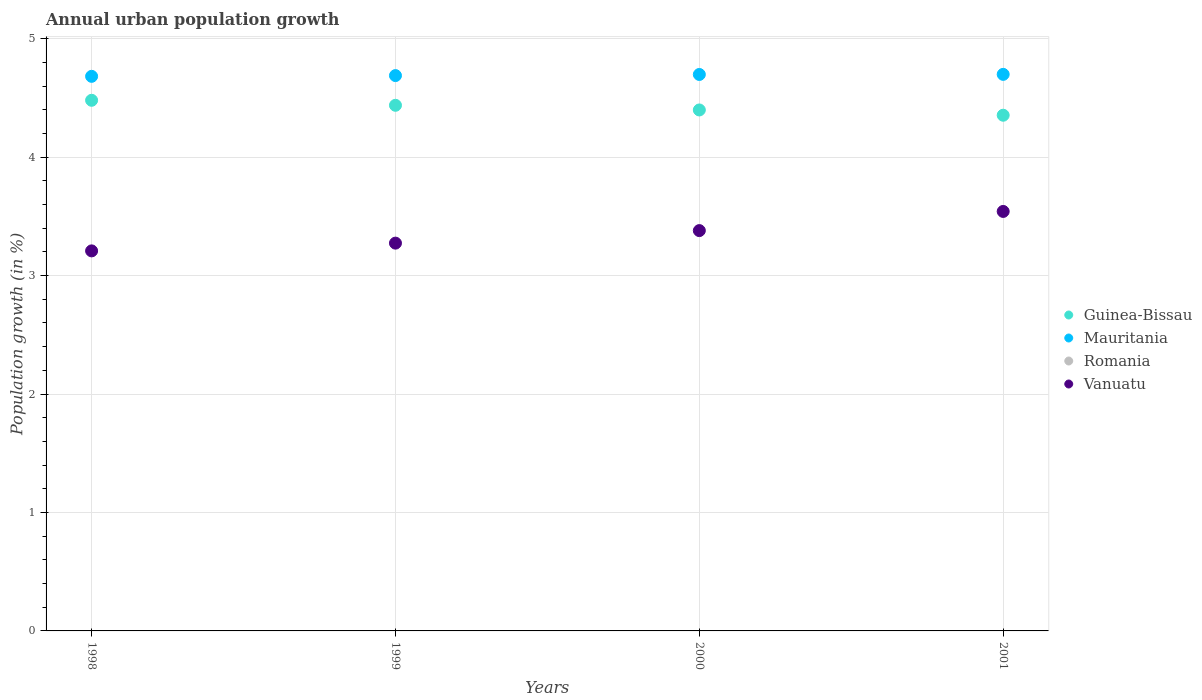Is the number of dotlines equal to the number of legend labels?
Provide a short and direct response. No. What is the percentage of urban population growth in Mauritania in 1999?
Give a very brief answer. 4.69. Across all years, what is the maximum percentage of urban population growth in Guinea-Bissau?
Keep it short and to the point. 4.48. Across all years, what is the minimum percentage of urban population growth in Mauritania?
Provide a succinct answer. 4.68. In which year was the percentage of urban population growth in Guinea-Bissau maximum?
Ensure brevity in your answer.  1998. What is the total percentage of urban population growth in Mauritania in the graph?
Provide a succinct answer. 18.77. What is the difference between the percentage of urban population growth in Guinea-Bissau in 1998 and that in 2001?
Keep it short and to the point. 0.13. What is the difference between the percentage of urban population growth in Guinea-Bissau in 1998 and the percentage of urban population growth in Mauritania in 2000?
Keep it short and to the point. -0.22. What is the average percentage of urban population growth in Romania per year?
Your answer should be compact. 0. In the year 1998, what is the difference between the percentage of urban population growth in Mauritania and percentage of urban population growth in Vanuatu?
Your answer should be compact. 1.47. In how many years, is the percentage of urban population growth in Romania greater than 0.8 %?
Offer a terse response. 0. What is the ratio of the percentage of urban population growth in Guinea-Bissau in 1998 to that in 1999?
Offer a terse response. 1.01. What is the difference between the highest and the second highest percentage of urban population growth in Vanuatu?
Your answer should be compact. 0.16. What is the difference between the highest and the lowest percentage of urban population growth in Mauritania?
Offer a very short reply. 0.02. Does the percentage of urban population growth in Vanuatu monotonically increase over the years?
Your answer should be very brief. Yes. Is the percentage of urban population growth in Mauritania strictly less than the percentage of urban population growth in Guinea-Bissau over the years?
Your answer should be compact. No. Are the values on the major ticks of Y-axis written in scientific E-notation?
Offer a terse response. No. How are the legend labels stacked?
Provide a succinct answer. Vertical. What is the title of the graph?
Offer a terse response. Annual urban population growth. What is the label or title of the Y-axis?
Keep it short and to the point. Population growth (in %). What is the Population growth (in %) of Guinea-Bissau in 1998?
Offer a very short reply. 4.48. What is the Population growth (in %) in Mauritania in 1998?
Keep it short and to the point. 4.68. What is the Population growth (in %) in Romania in 1998?
Offer a very short reply. 0. What is the Population growth (in %) of Vanuatu in 1998?
Provide a succinct answer. 3.21. What is the Population growth (in %) in Guinea-Bissau in 1999?
Your answer should be compact. 4.44. What is the Population growth (in %) of Mauritania in 1999?
Provide a short and direct response. 4.69. What is the Population growth (in %) of Vanuatu in 1999?
Give a very brief answer. 3.27. What is the Population growth (in %) of Guinea-Bissau in 2000?
Your answer should be very brief. 4.4. What is the Population growth (in %) in Mauritania in 2000?
Your answer should be very brief. 4.7. What is the Population growth (in %) in Vanuatu in 2000?
Your response must be concise. 3.38. What is the Population growth (in %) in Guinea-Bissau in 2001?
Provide a succinct answer. 4.35. What is the Population growth (in %) of Mauritania in 2001?
Ensure brevity in your answer.  4.7. What is the Population growth (in %) of Vanuatu in 2001?
Ensure brevity in your answer.  3.54. Across all years, what is the maximum Population growth (in %) of Guinea-Bissau?
Provide a short and direct response. 4.48. Across all years, what is the maximum Population growth (in %) in Mauritania?
Give a very brief answer. 4.7. Across all years, what is the maximum Population growth (in %) of Vanuatu?
Your response must be concise. 3.54. Across all years, what is the minimum Population growth (in %) of Guinea-Bissau?
Make the answer very short. 4.35. Across all years, what is the minimum Population growth (in %) in Mauritania?
Offer a terse response. 4.68. Across all years, what is the minimum Population growth (in %) in Vanuatu?
Your answer should be very brief. 3.21. What is the total Population growth (in %) of Guinea-Bissau in the graph?
Your response must be concise. 17.67. What is the total Population growth (in %) of Mauritania in the graph?
Make the answer very short. 18.77. What is the total Population growth (in %) in Romania in the graph?
Ensure brevity in your answer.  0. What is the total Population growth (in %) of Vanuatu in the graph?
Ensure brevity in your answer.  13.4. What is the difference between the Population growth (in %) in Guinea-Bissau in 1998 and that in 1999?
Offer a very short reply. 0.04. What is the difference between the Population growth (in %) in Mauritania in 1998 and that in 1999?
Provide a succinct answer. -0.01. What is the difference between the Population growth (in %) of Vanuatu in 1998 and that in 1999?
Offer a very short reply. -0.07. What is the difference between the Population growth (in %) of Guinea-Bissau in 1998 and that in 2000?
Ensure brevity in your answer.  0.08. What is the difference between the Population growth (in %) in Mauritania in 1998 and that in 2000?
Give a very brief answer. -0.02. What is the difference between the Population growth (in %) in Vanuatu in 1998 and that in 2000?
Provide a short and direct response. -0.17. What is the difference between the Population growth (in %) in Guinea-Bissau in 1998 and that in 2001?
Ensure brevity in your answer.  0.13. What is the difference between the Population growth (in %) in Mauritania in 1998 and that in 2001?
Offer a very short reply. -0.02. What is the difference between the Population growth (in %) of Vanuatu in 1998 and that in 2001?
Provide a succinct answer. -0.33. What is the difference between the Population growth (in %) in Guinea-Bissau in 1999 and that in 2000?
Keep it short and to the point. 0.04. What is the difference between the Population growth (in %) in Mauritania in 1999 and that in 2000?
Your response must be concise. -0.01. What is the difference between the Population growth (in %) in Vanuatu in 1999 and that in 2000?
Keep it short and to the point. -0.11. What is the difference between the Population growth (in %) of Guinea-Bissau in 1999 and that in 2001?
Provide a short and direct response. 0.08. What is the difference between the Population growth (in %) in Mauritania in 1999 and that in 2001?
Ensure brevity in your answer.  -0.01. What is the difference between the Population growth (in %) of Vanuatu in 1999 and that in 2001?
Ensure brevity in your answer.  -0.27. What is the difference between the Population growth (in %) of Guinea-Bissau in 2000 and that in 2001?
Your response must be concise. 0.04. What is the difference between the Population growth (in %) in Mauritania in 2000 and that in 2001?
Your answer should be compact. -0. What is the difference between the Population growth (in %) in Vanuatu in 2000 and that in 2001?
Keep it short and to the point. -0.16. What is the difference between the Population growth (in %) in Guinea-Bissau in 1998 and the Population growth (in %) in Mauritania in 1999?
Keep it short and to the point. -0.21. What is the difference between the Population growth (in %) in Guinea-Bissau in 1998 and the Population growth (in %) in Vanuatu in 1999?
Provide a short and direct response. 1.21. What is the difference between the Population growth (in %) of Mauritania in 1998 and the Population growth (in %) of Vanuatu in 1999?
Offer a terse response. 1.41. What is the difference between the Population growth (in %) of Guinea-Bissau in 1998 and the Population growth (in %) of Mauritania in 2000?
Give a very brief answer. -0.22. What is the difference between the Population growth (in %) of Guinea-Bissau in 1998 and the Population growth (in %) of Vanuatu in 2000?
Offer a terse response. 1.1. What is the difference between the Population growth (in %) of Mauritania in 1998 and the Population growth (in %) of Vanuatu in 2000?
Your answer should be very brief. 1.3. What is the difference between the Population growth (in %) in Guinea-Bissau in 1998 and the Population growth (in %) in Mauritania in 2001?
Your answer should be compact. -0.22. What is the difference between the Population growth (in %) of Guinea-Bissau in 1998 and the Population growth (in %) of Vanuatu in 2001?
Offer a terse response. 0.94. What is the difference between the Population growth (in %) of Mauritania in 1998 and the Population growth (in %) of Vanuatu in 2001?
Make the answer very short. 1.14. What is the difference between the Population growth (in %) in Guinea-Bissau in 1999 and the Population growth (in %) in Mauritania in 2000?
Keep it short and to the point. -0.26. What is the difference between the Population growth (in %) of Guinea-Bissau in 1999 and the Population growth (in %) of Vanuatu in 2000?
Your response must be concise. 1.06. What is the difference between the Population growth (in %) of Mauritania in 1999 and the Population growth (in %) of Vanuatu in 2000?
Give a very brief answer. 1.31. What is the difference between the Population growth (in %) in Guinea-Bissau in 1999 and the Population growth (in %) in Mauritania in 2001?
Ensure brevity in your answer.  -0.26. What is the difference between the Population growth (in %) in Guinea-Bissau in 1999 and the Population growth (in %) in Vanuatu in 2001?
Provide a succinct answer. 0.9. What is the difference between the Population growth (in %) in Mauritania in 1999 and the Population growth (in %) in Vanuatu in 2001?
Provide a short and direct response. 1.15. What is the difference between the Population growth (in %) of Guinea-Bissau in 2000 and the Population growth (in %) of Mauritania in 2001?
Make the answer very short. -0.3. What is the difference between the Population growth (in %) in Guinea-Bissau in 2000 and the Population growth (in %) in Vanuatu in 2001?
Give a very brief answer. 0.86. What is the difference between the Population growth (in %) of Mauritania in 2000 and the Population growth (in %) of Vanuatu in 2001?
Your answer should be compact. 1.16. What is the average Population growth (in %) in Guinea-Bissau per year?
Your answer should be compact. 4.42. What is the average Population growth (in %) in Mauritania per year?
Ensure brevity in your answer.  4.69. What is the average Population growth (in %) of Romania per year?
Provide a succinct answer. 0. What is the average Population growth (in %) in Vanuatu per year?
Make the answer very short. 3.35. In the year 1998, what is the difference between the Population growth (in %) of Guinea-Bissau and Population growth (in %) of Mauritania?
Ensure brevity in your answer.  -0.2. In the year 1998, what is the difference between the Population growth (in %) of Guinea-Bissau and Population growth (in %) of Vanuatu?
Provide a succinct answer. 1.27. In the year 1998, what is the difference between the Population growth (in %) of Mauritania and Population growth (in %) of Vanuatu?
Make the answer very short. 1.47. In the year 1999, what is the difference between the Population growth (in %) of Guinea-Bissau and Population growth (in %) of Mauritania?
Your answer should be very brief. -0.25. In the year 1999, what is the difference between the Population growth (in %) of Guinea-Bissau and Population growth (in %) of Vanuatu?
Provide a short and direct response. 1.16. In the year 1999, what is the difference between the Population growth (in %) of Mauritania and Population growth (in %) of Vanuatu?
Provide a short and direct response. 1.41. In the year 2000, what is the difference between the Population growth (in %) in Guinea-Bissau and Population growth (in %) in Mauritania?
Provide a short and direct response. -0.3. In the year 2000, what is the difference between the Population growth (in %) of Guinea-Bissau and Population growth (in %) of Vanuatu?
Your answer should be compact. 1.02. In the year 2000, what is the difference between the Population growth (in %) of Mauritania and Population growth (in %) of Vanuatu?
Provide a succinct answer. 1.32. In the year 2001, what is the difference between the Population growth (in %) of Guinea-Bissau and Population growth (in %) of Mauritania?
Your answer should be very brief. -0.34. In the year 2001, what is the difference between the Population growth (in %) in Guinea-Bissau and Population growth (in %) in Vanuatu?
Ensure brevity in your answer.  0.81. In the year 2001, what is the difference between the Population growth (in %) in Mauritania and Population growth (in %) in Vanuatu?
Provide a short and direct response. 1.16. What is the ratio of the Population growth (in %) in Guinea-Bissau in 1998 to that in 1999?
Ensure brevity in your answer.  1.01. What is the ratio of the Population growth (in %) of Vanuatu in 1998 to that in 1999?
Offer a terse response. 0.98. What is the ratio of the Population growth (in %) of Guinea-Bissau in 1998 to that in 2000?
Your response must be concise. 1.02. What is the ratio of the Population growth (in %) in Vanuatu in 1998 to that in 2000?
Give a very brief answer. 0.95. What is the ratio of the Population growth (in %) in Guinea-Bissau in 1998 to that in 2001?
Your response must be concise. 1.03. What is the ratio of the Population growth (in %) in Vanuatu in 1998 to that in 2001?
Your answer should be very brief. 0.91. What is the ratio of the Population growth (in %) of Mauritania in 1999 to that in 2000?
Ensure brevity in your answer.  1. What is the ratio of the Population growth (in %) of Vanuatu in 1999 to that in 2000?
Offer a very short reply. 0.97. What is the ratio of the Population growth (in %) in Guinea-Bissau in 1999 to that in 2001?
Your answer should be very brief. 1.02. What is the ratio of the Population growth (in %) of Vanuatu in 1999 to that in 2001?
Ensure brevity in your answer.  0.92. What is the ratio of the Population growth (in %) of Guinea-Bissau in 2000 to that in 2001?
Offer a terse response. 1.01. What is the ratio of the Population growth (in %) in Vanuatu in 2000 to that in 2001?
Give a very brief answer. 0.95. What is the difference between the highest and the second highest Population growth (in %) in Guinea-Bissau?
Keep it short and to the point. 0.04. What is the difference between the highest and the second highest Population growth (in %) in Mauritania?
Make the answer very short. 0. What is the difference between the highest and the second highest Population growth (in %) in Vanuatu?
Make the answer very short. 0.16. What is the difference between the highest and the lowest Population growth (in %) of Guinea-Bissau?
Make the answer very short. 0.13. What is the difference between the highest and the lowest Population growth (in %) in Mauritania?
Give a very brief answer. 0.02. What is the difference between the highest and the lowest Population growth (in %) in Vanuatu?
Ensure brevity in your answer.  0.33. 